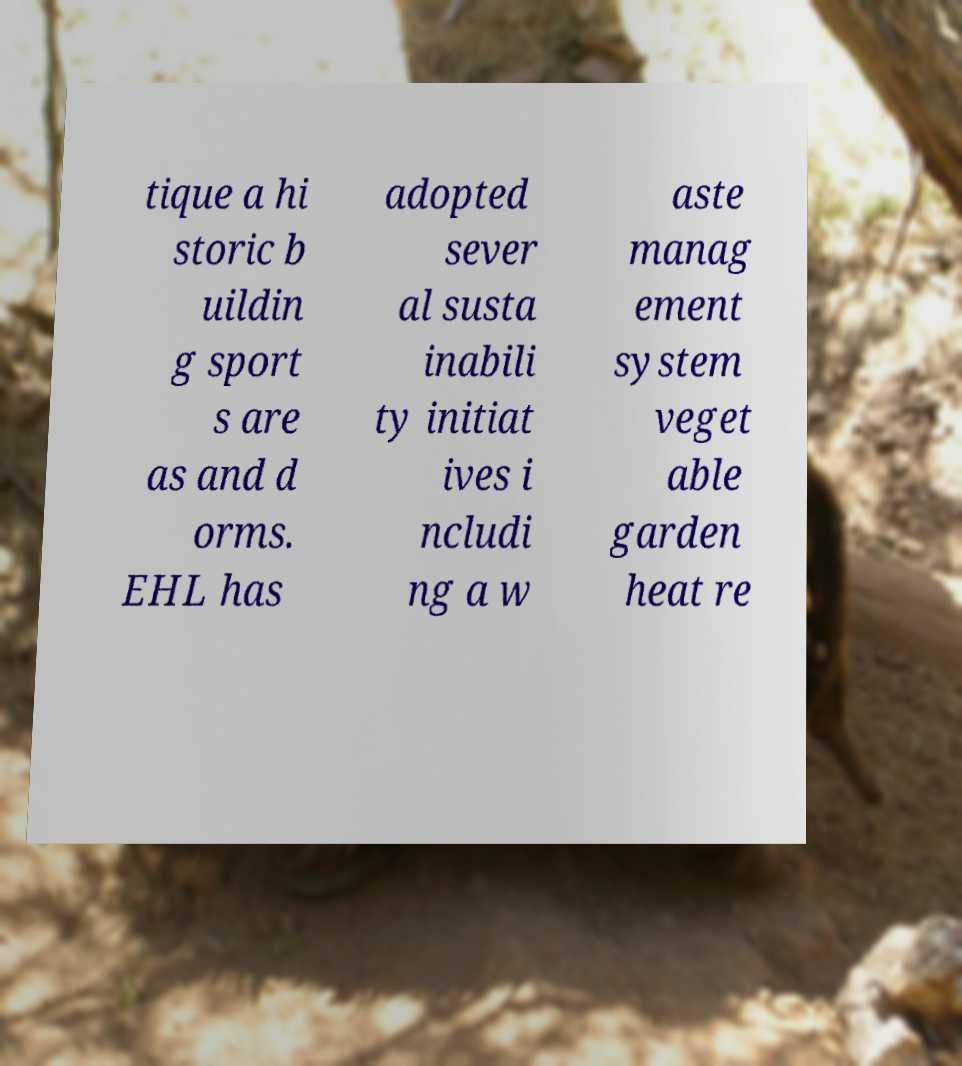I need the written content from this picture converted into text. Can you do that? tique a hi storic b uildin g sport s are as and d orms. EHL has adopted sever al susta inabili ty initiat ives i ncludi ng a w aste manag ement system veget able garden heat re 